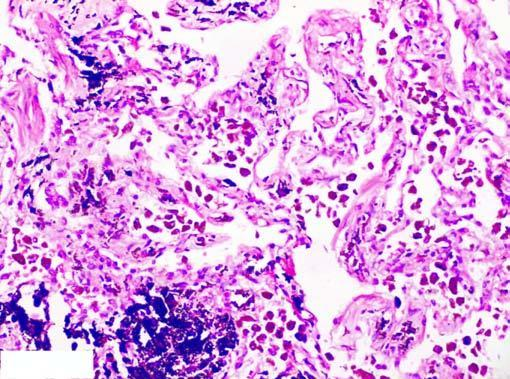s there presence of abundant coarse black carbon pigment in the septal walls and around the bronchiole?
Answer the question using a single word or phrase. Yes 